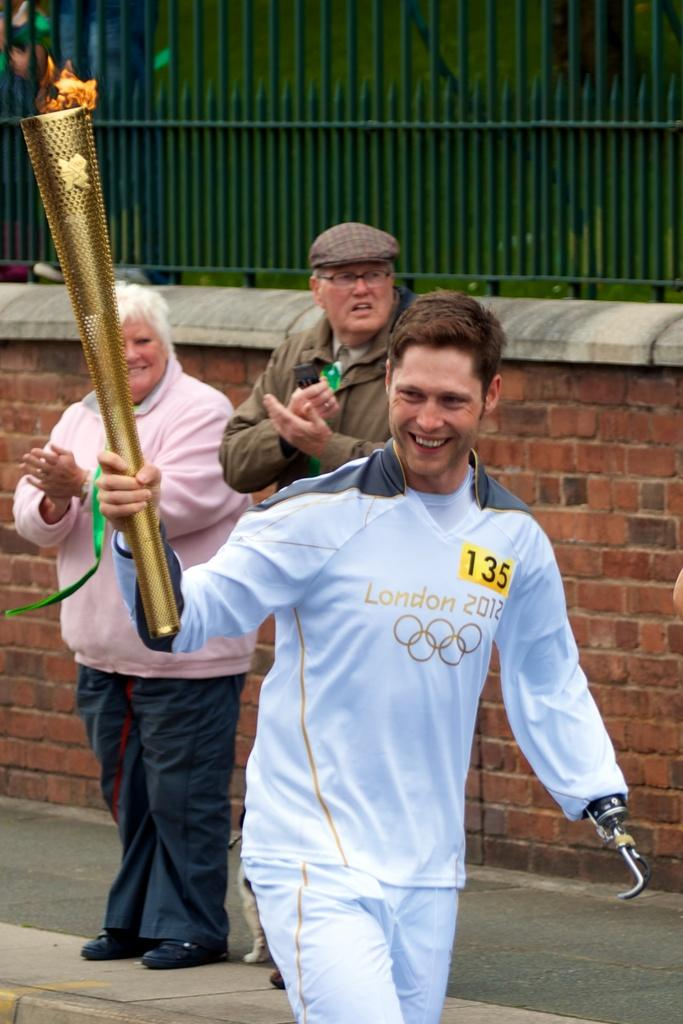<image>
Describe the image concisely. a person holding a London torch for other people 